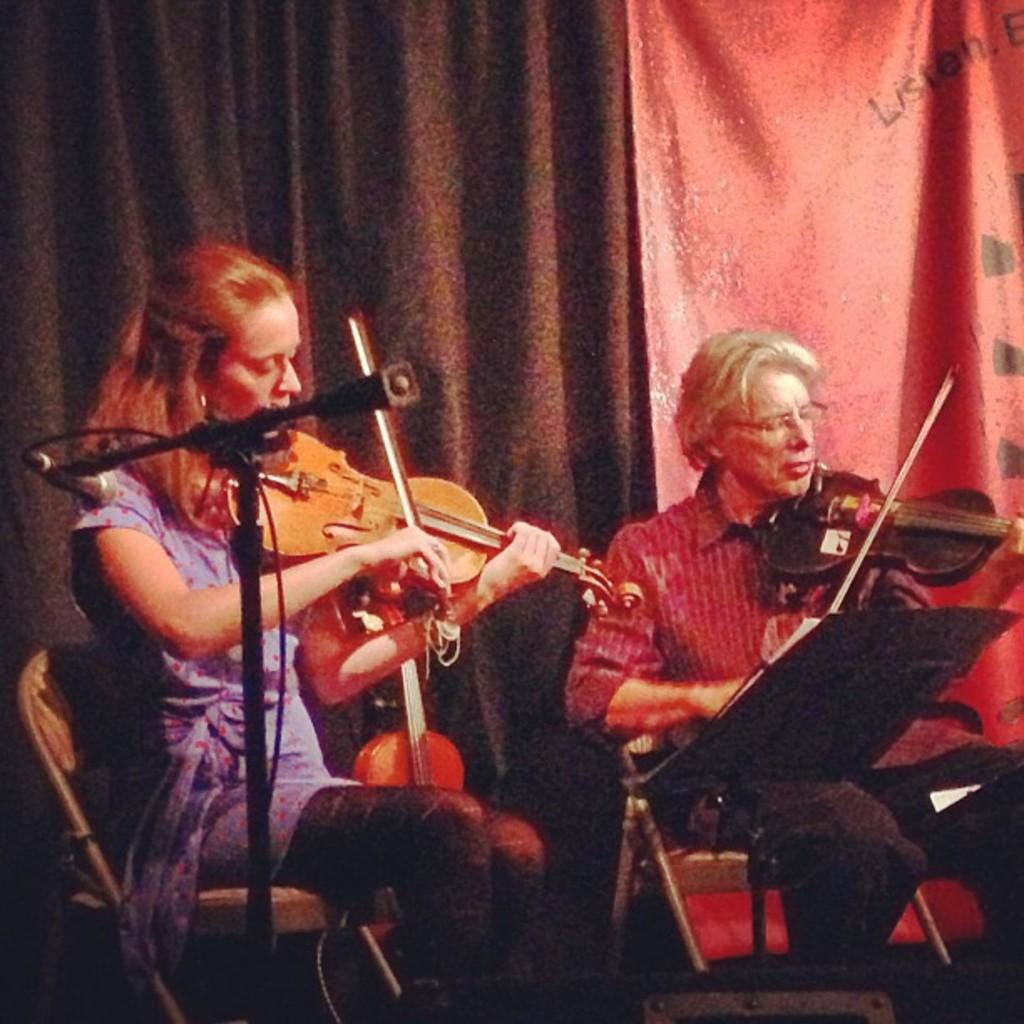What can be seen in the background of the image? There are curtains in the background of the image. What colors are the curtains? The curtains are brown and red in color. How many people are in the image? There are two people in the image, a man and a woman. What are the man and woman doing in the image? The man and woman are sitting on chairs and playing violins. What is in front of the man and woman? Both the man and woman are in front of a microphone. Can you see any fowl in the image? No, there are no fowl present in the image. Is there a hydrant visible in the image? No, there is no hydrant present in the image. 